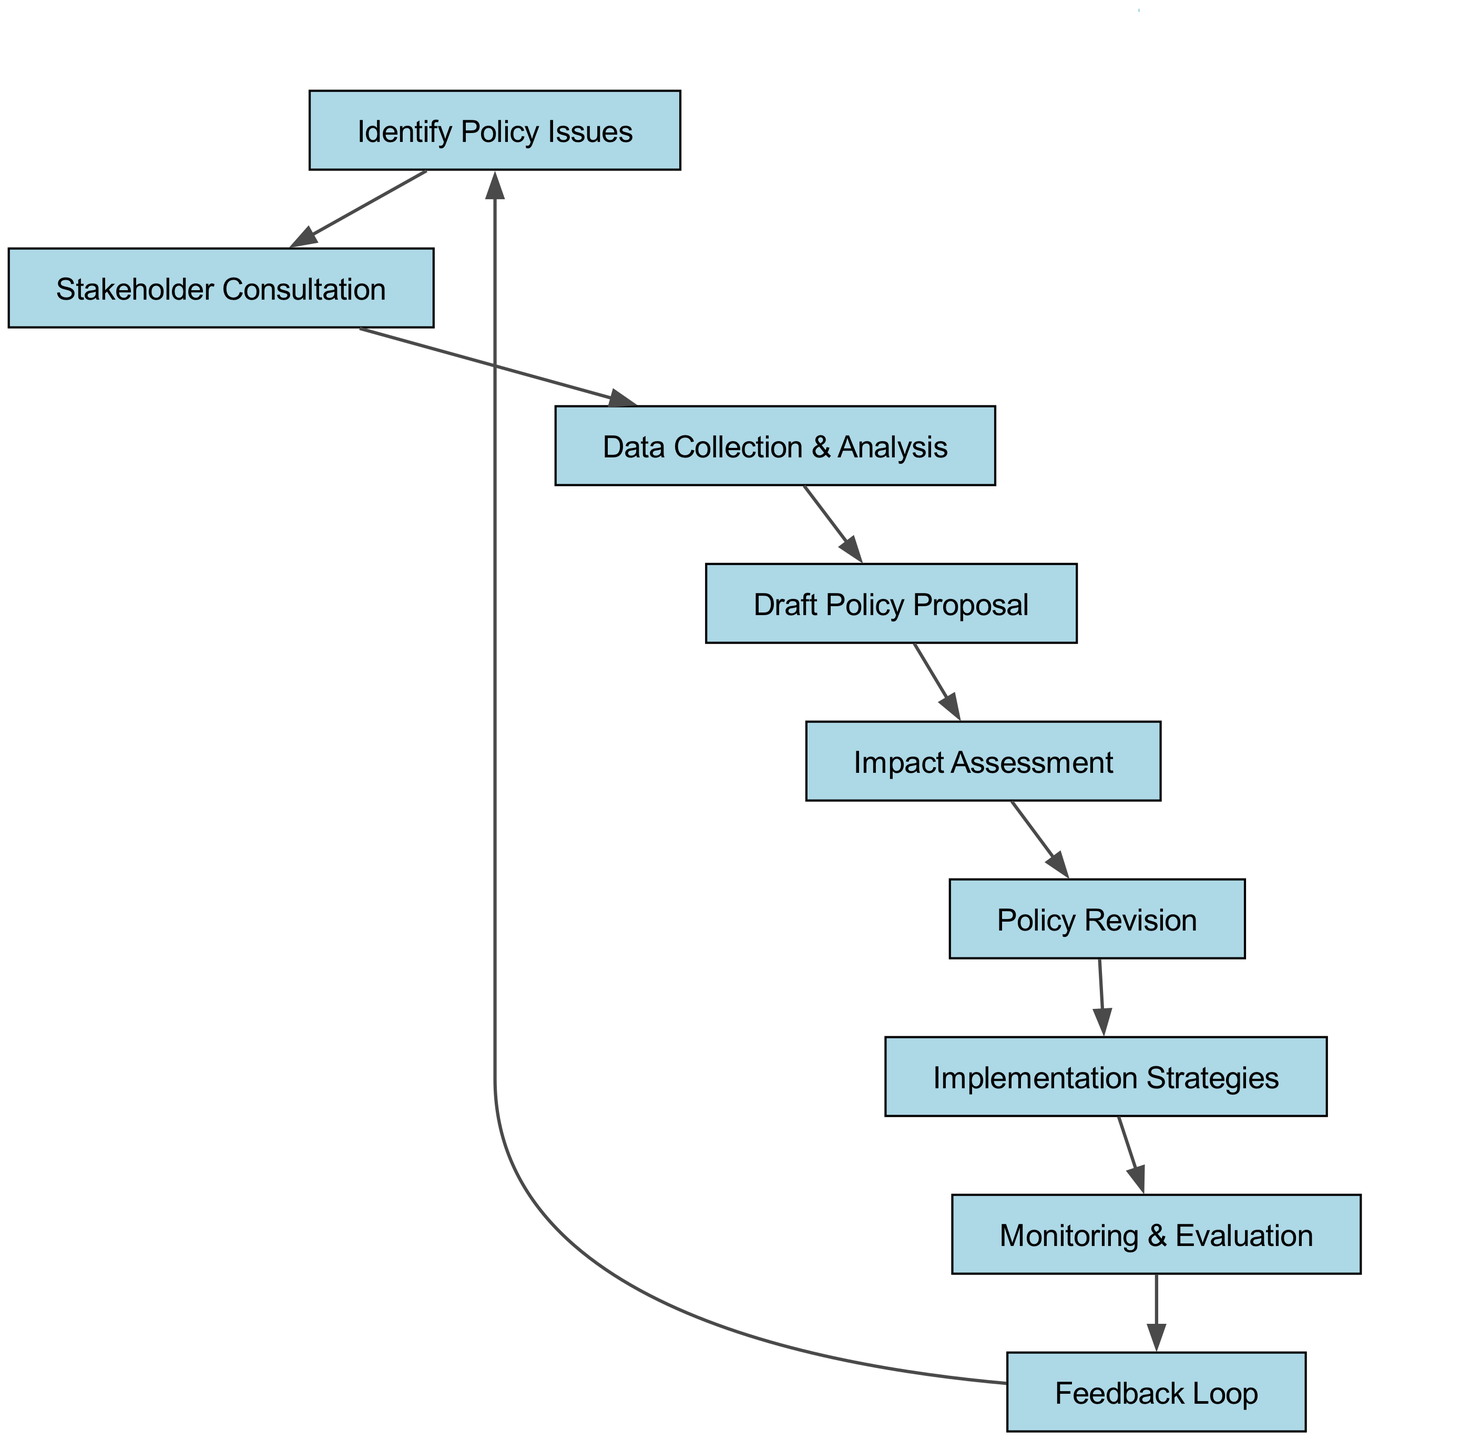What is the first step in the healthcare policy decision-making process? The diagram shows that the first step is represented by node "A", which is "Identify Policy Issues."
Answer: Identify Policy Issues How many total nodes are present in the diagram? By counting the nodes listed, there are 9 total nodes in the diagram: A, B, C, D, E, F, G, H, I.
Answer: 9 Which node follows "Stakeholder Consultation"? According to the directed edges in the diagram, "Stakeholder Consultation" is node "B", and it is followed by "Data Collection & Analysis," which is node "C."
Answer: Data Collection & Analysis What is the relationship between "Impact Assessment" and "Policy Revision"? The diagram shows a directed edge from "Impact Assessment," which is node "E," to "Policy Revision," which is node "F," indicating "Impact Assessment" leads to "Policy Revision."
Answer: Impact Assessment leads to Policy Revision In which node does the feedback loop begin? The feedback loop starts from node "I," which is labeled "Feedback Loop" and connects back to "Identify Policy Issues," completing the cycle.
Answer: Feedback Loop What is the last node before the implementation stage in the process? The last node before "Implementation Strategies," which is node "G," is "Policy Revision," labeled as node "F."
Answer: Policy Revision How many edges are in the directed graph? By analyzing the edges provided, there are a total of 8 directed edges connecting the nodes in the diagram, indicating the flow of the process.
Answer: 8 Which nodes form the first three steps in the decision-making process? The first three nodes based on the directed connections are "Identify Policy Issues" (A), "Stakeholder Consultation" (B), and "Data Collection & Analysis" (C) indicating the starting sequence of the process.
Answer: Identify Policy Issues, Stakeholder Consultation, Data Collection & Analysis What is the final step of the healthcare policy decision-making process? The diagram indicates that the final step is represented by node "I," which is "Feedback Loop," completing the process before it cycles back to the start.
Answer: Feedback Loop 